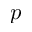Convert formula to latex. <formula><loc_0><loc_0><loc_500><loc_500>p</formula> 